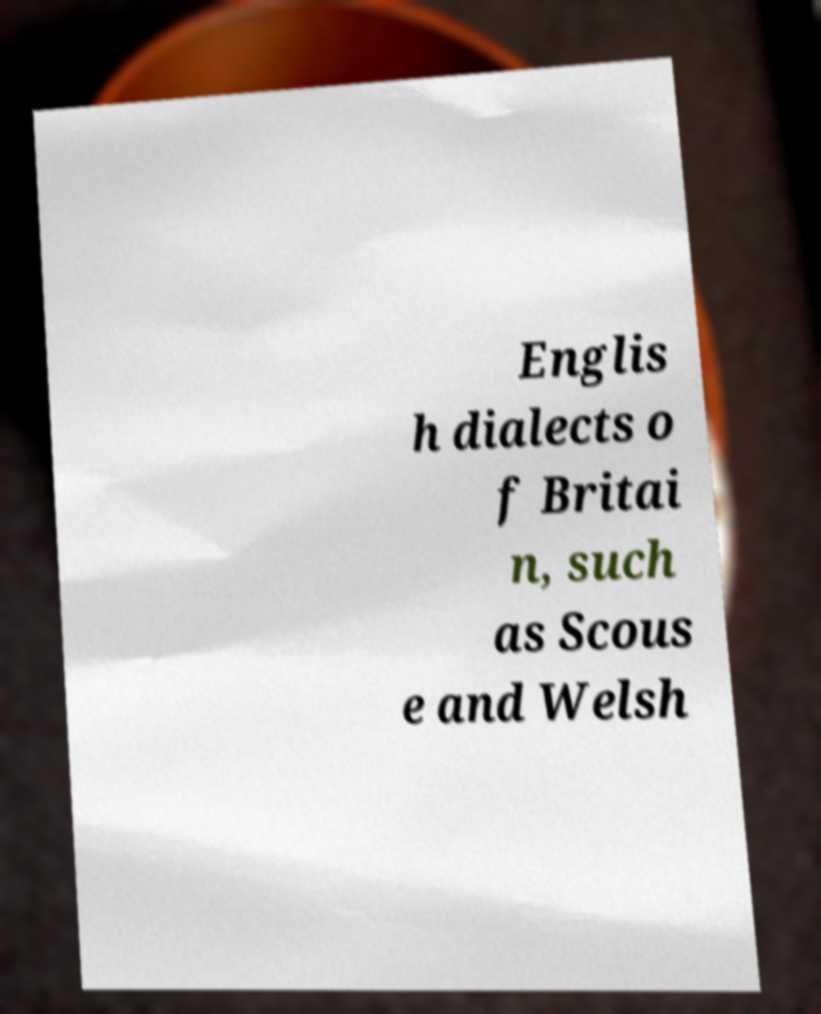Please identify and transcribe the text found in this image. Englis h dialects o f Britai n, such as Scous e and Welsh 